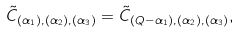<formula> <loc_0><loc_0><loc_500><loc_500>\tilde { C } _ { ( \alpha _ { 1 } ) , ( \alpha _ { 2 } ) , ( \alpha _ { 3 } ) } = \tilde { C } _ { ( Q - \alpha _ { 1 } ) , ( \alpha _ { 2 } ) , ( \alpha _ { 3 } ) } ,</formula> 